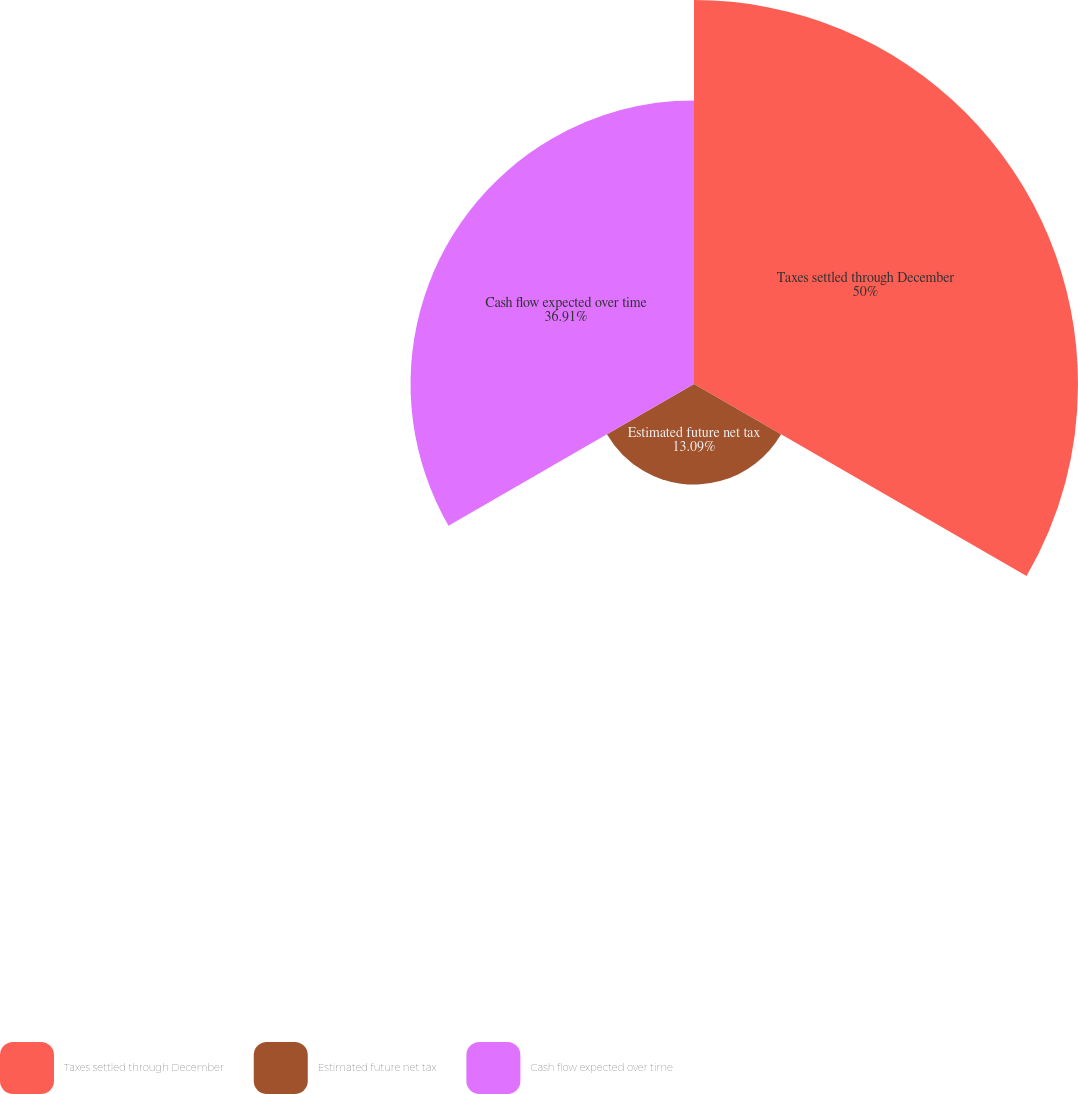Convert chart to OTSL. <chart><loc_0><loc_0><loc_500><loc_500><pie_chart><fcel>Taxes settled through December<fcel>Estimated future net tax<fcel>Cash flow expected over time<nl><fcel>50.0%<fcel>13.09%<fcel>36.91%<nl></chart> 